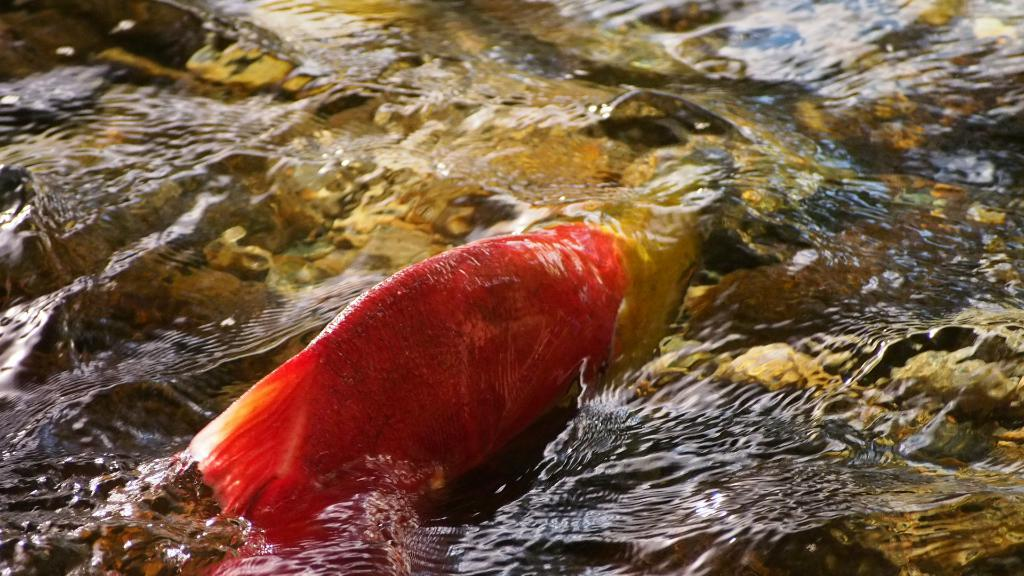What is the main subject of the image? There is a fish in the image. What is the fish doing in the image? The fish is swimming in the water. What type of pie is being served at the basketball game during the week in the image? There is no pie, basketball game, or reference to a week in the image; it only features a fish swimming in the water. 